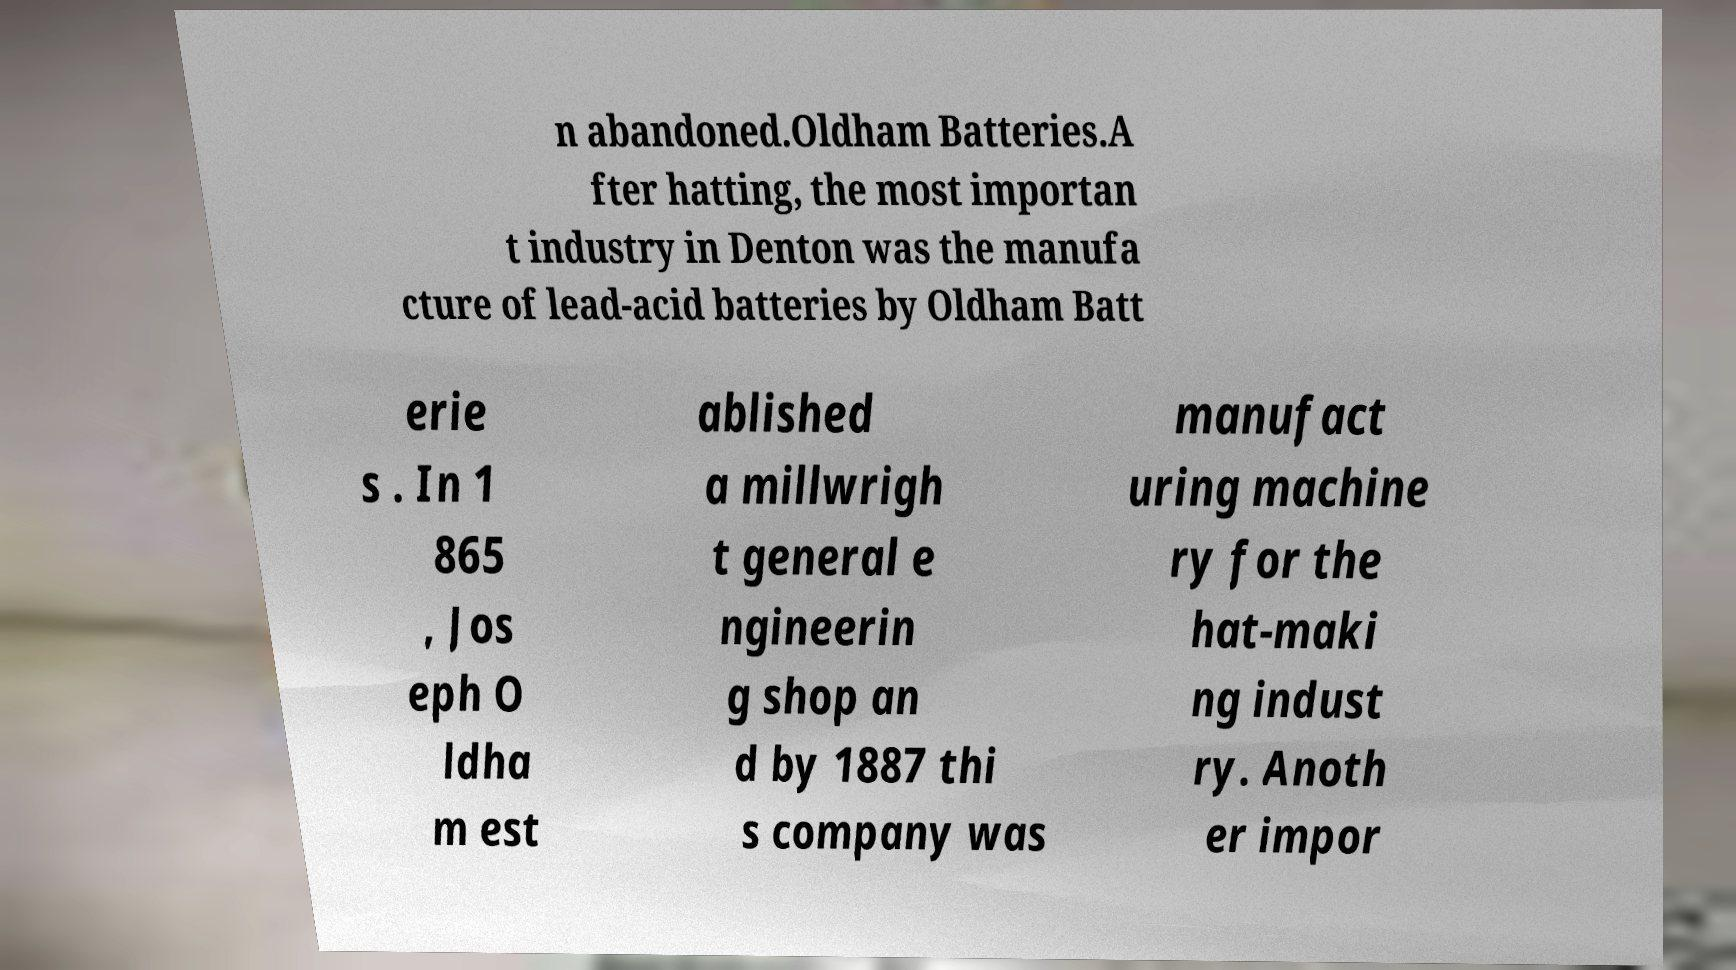What messages or text are displayed in this image? I need them in a readable, typed format. n abandoned.Oldham Batteries.A fter hatting, the most importan t industry in Denton was the manufa cture of lead-acid batteries by Oldham Batt erie s . In 1 865 , Jos eph O ldha m est ablished a millwrigh t general e ngineerin g shop an d by 1887 thi s company was manufact uring machine ry for the hat-maki ng indust ry. Anoth er impor 